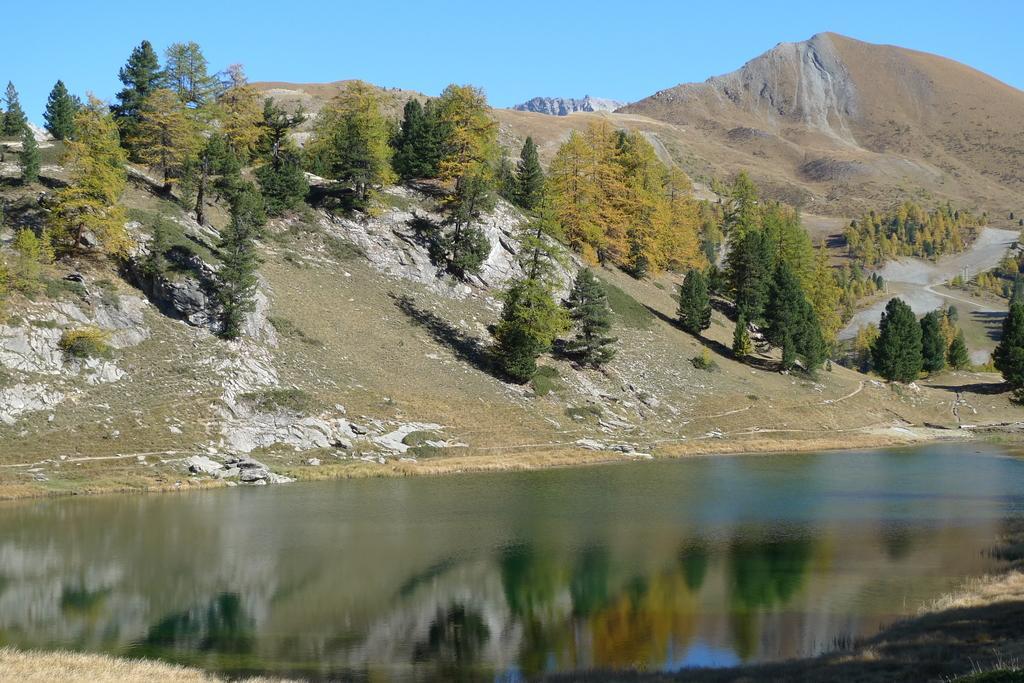Can you describe this image briefly? In this image we can see a lake in the middle of the image and there are some mountains. We can see some trees and there is a path in between the trees and at the top we can see the sky. 